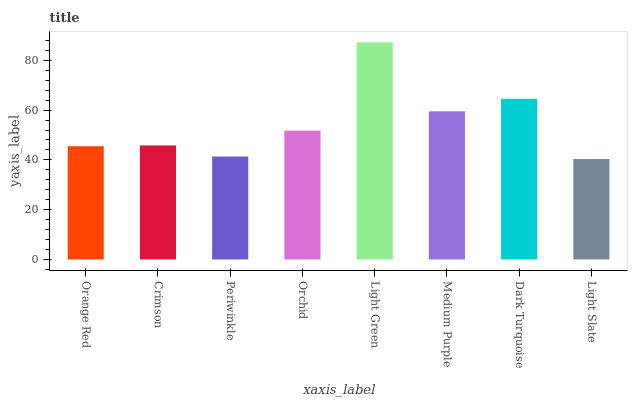Is Light Slate the minimum?
Answer yes or no. Yes. Is Light Green the maximum?
Answer yes or no. Yes. Is Crimson the minimum?
Answer yes or no. No. Is Crimson the maximum?
Answer yes or no. No. Is Crimson greater than Orange Red?
Answer yes or no. Yes. Is Orange Red less than Crimson?
Answer yes or no. Yes. Is Orange Red greater than Crimson?
Answer yes or no. No. Is Crimson less than Orange Red?
Answer yes or no. No. Is Orchid the high median?
Answer yes or no. Yes. Is Crimson the low median?
Answer yes or no. Yes. Is Crimson the high median?
Answer yes or no. No. Is Medium Purple the low median?
Answer yes or no. No. 